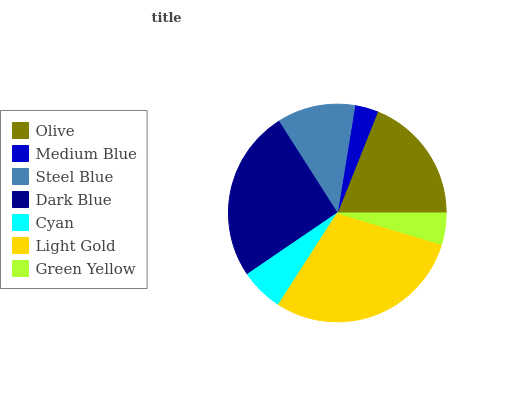Is Medium Blue the minimum?
Answer yes or no. Yes. Is Light Gold the maximum?
Answer yes or no. Yes. Is Steel Blue the minimum?
Answer yes or no. No. Is Steel Blue the maximum?
Answer yes or no. No. Is Steel Blue greater than Medium Blue?
Answer yes or no. Yes. Is Medium Blue less than Steel Blue?
Answer yes or no. Yes. Is Medium Blue greater than Steel Blue?
Answer yes or no. No. Is Steel Blue less than Medium Blue?
Answer yes or no. No. Is Steel Blue the high median?
Answer yes or no. Yes. Is Steel Blue the low median?
Answer yes or no. Yes. Is Green Yellow the high median?
Answer yes or no. No. Is Light Gold the low median?
Answer yes or no. No. 